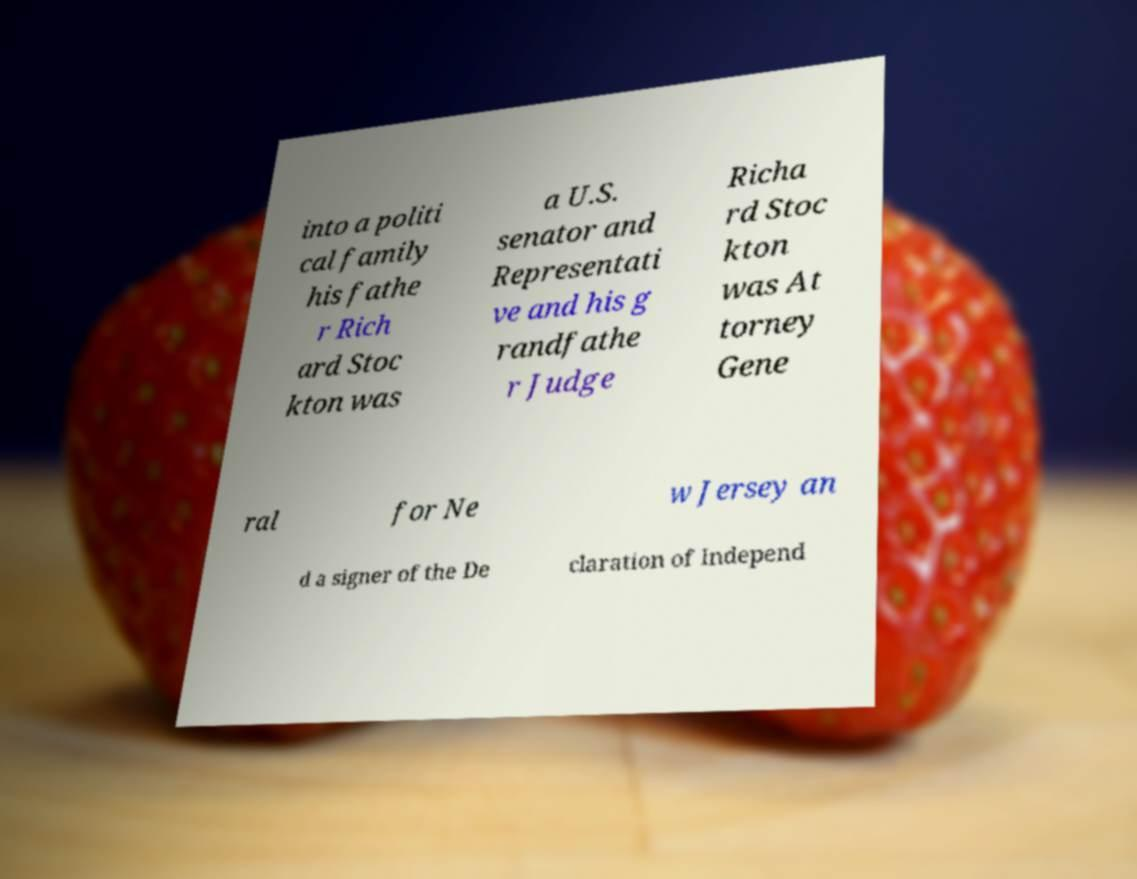There's text embedded in this image that I need extracted. Can you transcribe it verbatim? into a politi cal family his fathe r Rich ard Stoc kton was a U.S. senator and Representati ve and his g randfathe r Judge Richa rd Stoc kton was At torney Gene ral for Ne w Jersey an d a signer of the De claration of Independ 